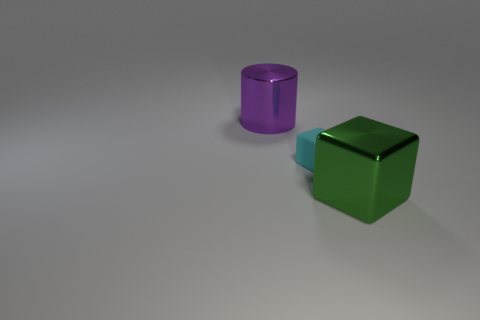How many other big shiny objects are the same shape as the green metal object? There are no other objects that share the same shape as the green cube in the image. The only other object present is a purple cylinder, which is different in shape. 